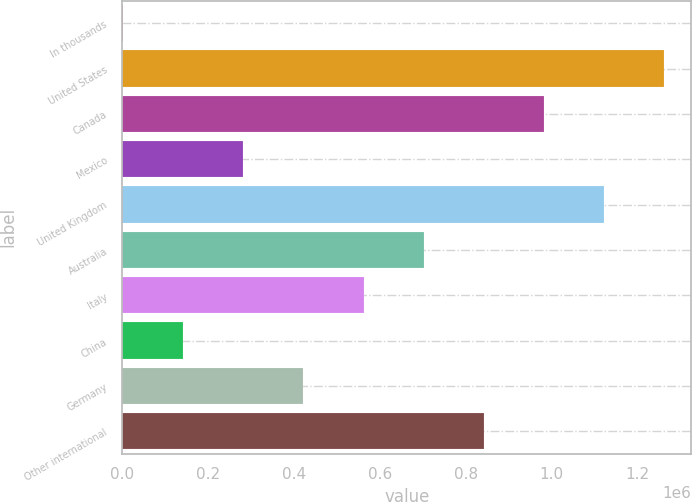Convert chart. <chart><loc_0><loc_0><loc_500><loc_500><bar_chart><fcel>In thousands<fcel>United States<fcel>Canada<fcel>Mexico<fcel>United Kingdom<fcel>Australia<fcel>Italy<fcel>China<fcel>Germany<fcel>Other international<nl><fcel>2009<fcel>1.26166e+06<fcel>981734<fcel>281930<fcel>1.12169e+06<fcel>701812<fcel>561852<fcel>141970<fcel>421891<fcel>841773<nl></chart> 